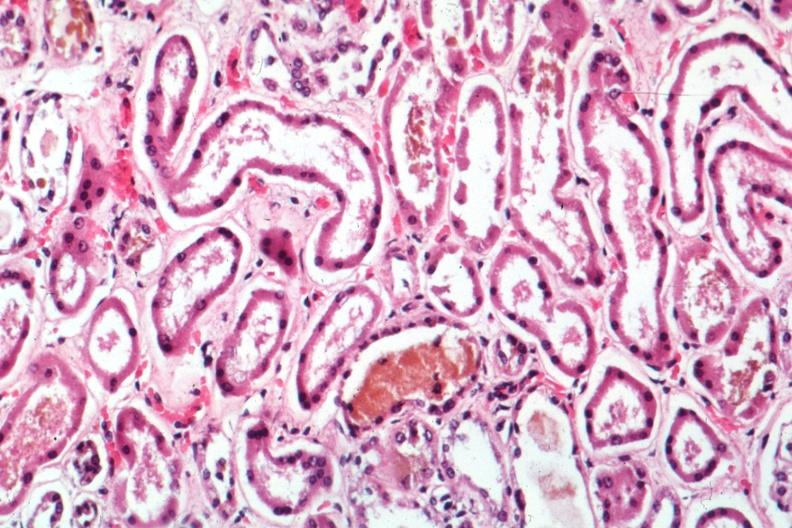how does this image show mad dilated tubules?
Answer the question using a single word or phrase. With missing and pyknotic nuclei and bile in one quite good 